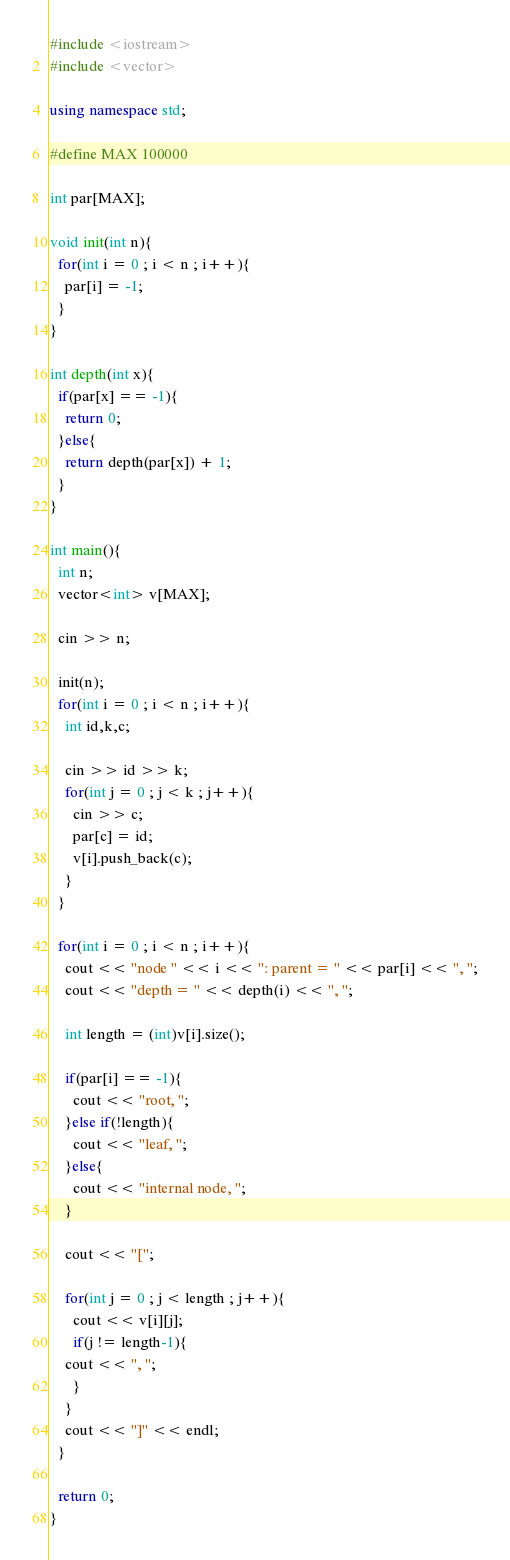<code> <loc_0><loc_0><loc_500><loc_500><_C++_>#include <iostream>
#include <vector>

using namespace std;

#define MAX 100000

int par[MAX];

void init(int n){
  for(int i = 0 ; i < n ; i++){
    par[i] = -1;
  }
}

int depth(int x){
  if(par[x] == -1){
    return 0;
  }else{
    return depth(par[x]) + 1;
  }
}

int main(){
  int n;
  vector<int> v[MAX];

  cin >> n;

  init(n);
  for(int i = 0 ; i < n ; i++){
    int id,k,c;

    cin >> id >> k;
    for(int j = 0 ; j < k ; j++){
      cin >> c;
      par[c] = id;
      v[i].push_back(c);
    }
  }

  for(int i = 0 ; i < n ; i++){
    cout << "node " << i << ": parent = " << par[i] << ", ";
    cout << "depth = " << depth(i) << ", ";

    int length = (int)v[i].size();

    if(par[i] == -1){
      cout << "root, ";
    }else if(!length){
      cout << "leaf, ";
    }else{
      cout << "internal node, ";
    }

    cout << "[";
    
    for(int j = 0 ; j < length ; j++){
      cout << v[i][j];
      if(j != length-1){
	cout << ", ";
      }
    }
    cout << "]" << endl;
  }

  return 0;
}</code> 